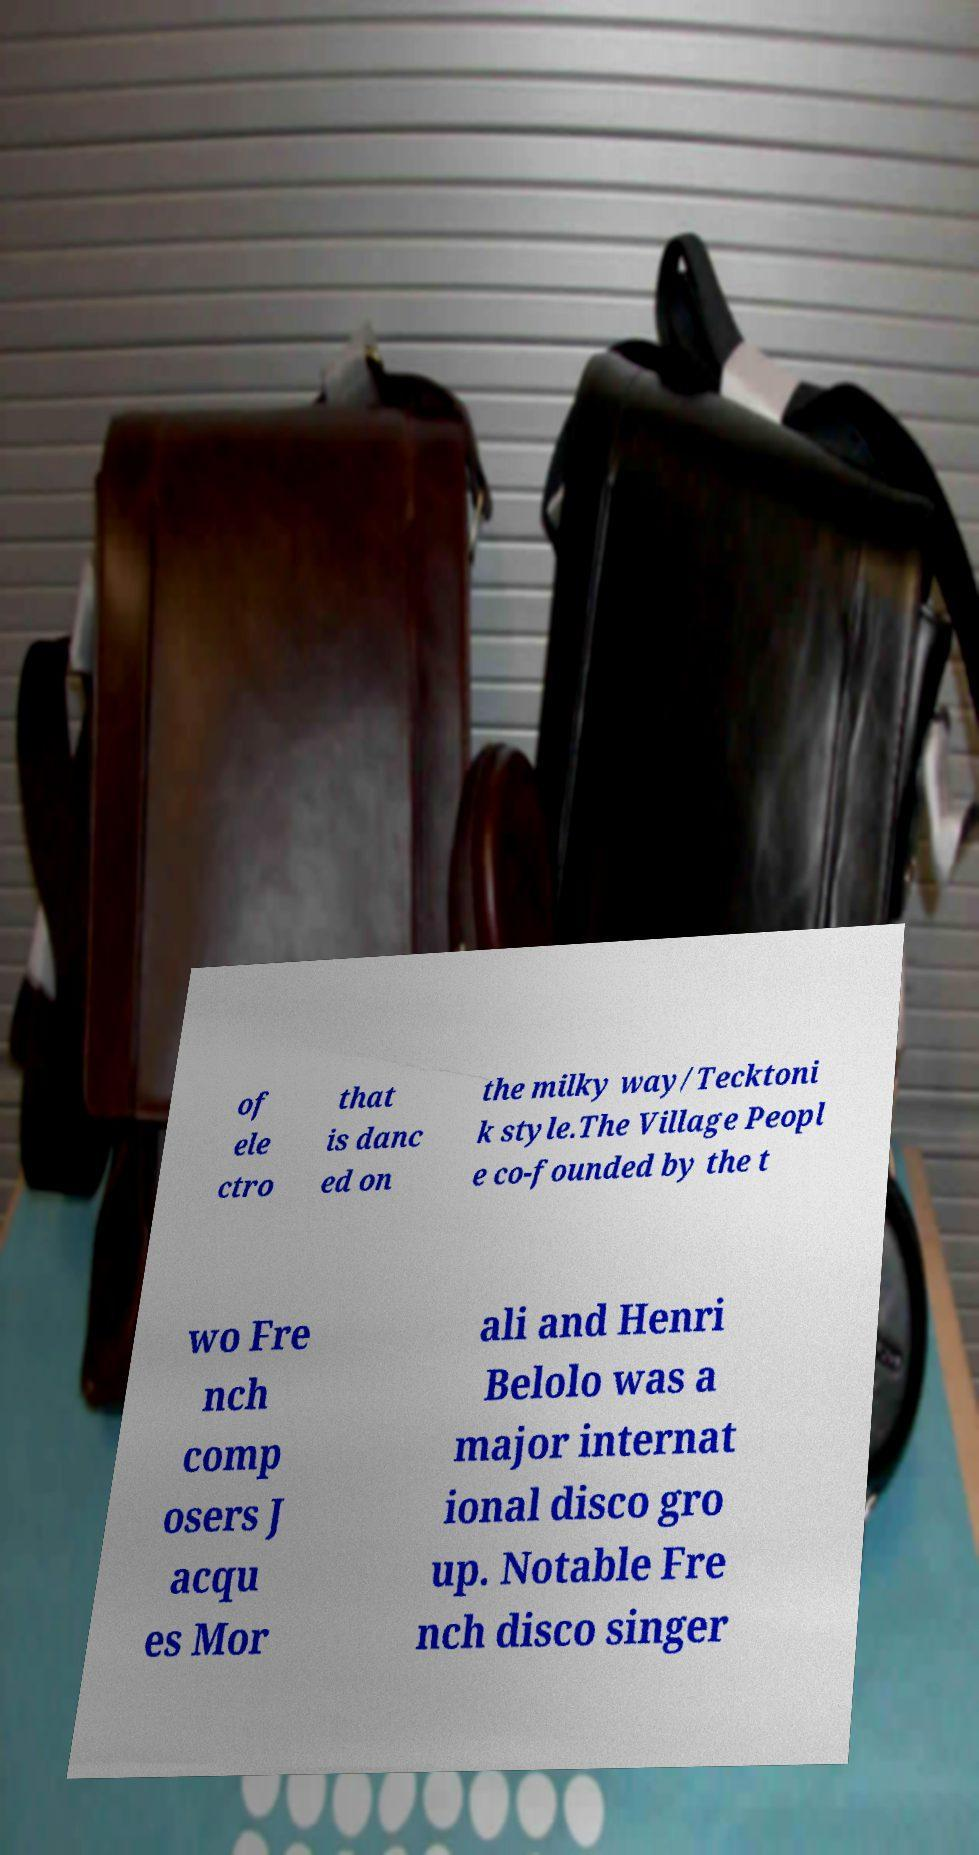There's text embedded in this image that I need extracted. Can you transcribe it verbatim? of ele ctro that is danc ed on the milky way/Tecktoni k style.The Village Peopl e co-founded by the t wo Fre nch comp osers J acqu es Mor ali and Henri Belolo was a major internat ional disco gro up. Notable Fre nch disco singer 